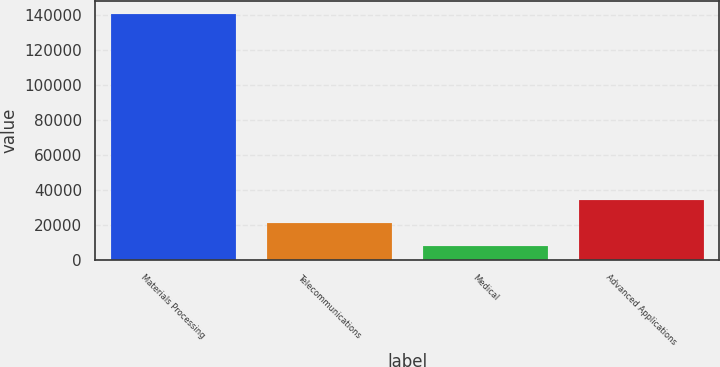<chart> <loc_0><loc_0><loc_500><loc_500><bar_chart><fcel>Materials Processing<fcel>Telecommunications<fcel>Medical<fcel>Advanced Applications<nl><fcel>140864<fcel>20931.8<fcel>7606<fcel>34257.6<nl></chart> 